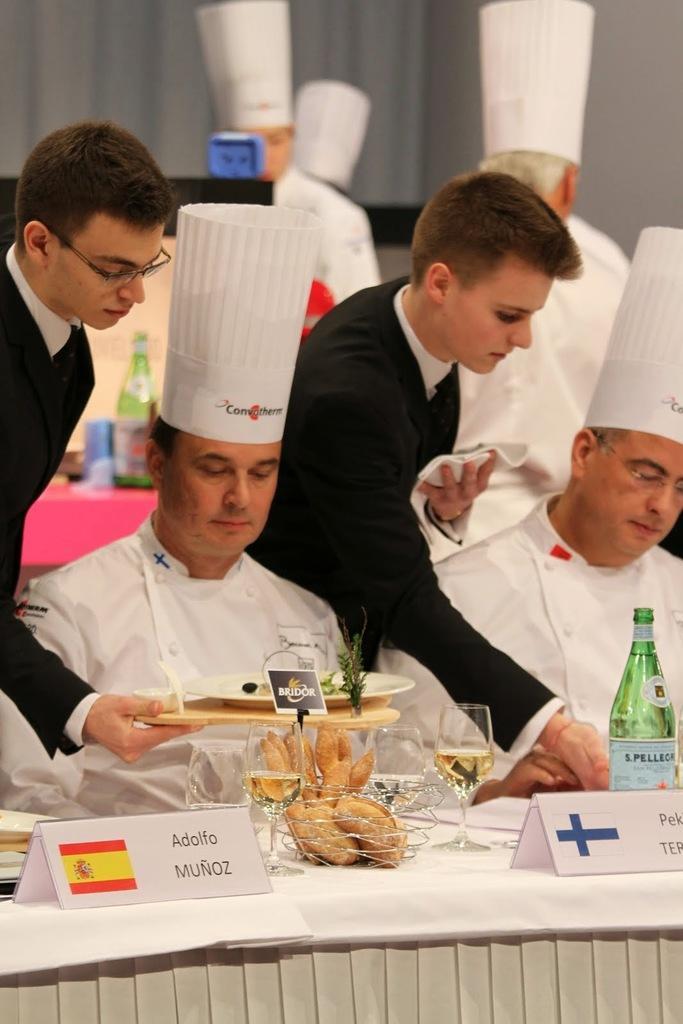Please provide a concise description of this image. In this image there are people who are sitting and eating,while the other two people are serving for the people who are sitting,on the table there is glass wine,food,plate and board. 